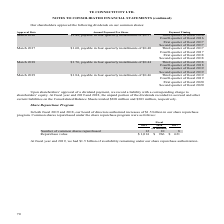According to Te Connectivity's financial document, What was authorized by the board of directors in 2018 and 2019? increases of $1.5 billion in our share repurchase program. The document states: "2019 and 2018, our board of directors authorized increases of $1.5 billion in our share repurchase program. Common shares repurchased under the share ..." Also, What was the availability remaining under the share repurchase authorization in 2019? According to the financial document, $1.5 billion. The relevant text states: "18, our board of directors authorized increases of $1.5 billion in our share repurchase..." Also, Which years was the Repurchase value calculated in? The document contains multiple relevant values: 2019, 2018, 2017. From the document: "2019 2018 2017 2019 2018 2017 2019 2018 2017..." Additionally, Which year was the Number of common shares repurchased the largest? According to the financial document, 2019. The relevant text states: "2019 2018 2017..." Also, can you calculate: What was the change in the Number of common shares repurchased in 2019 from 2018? Based on the calculation: 12-10, the result is 2 (in millions). This is based on the information: "Number of common shares repurchased 12 10 8 Number of common shares repurchased 12 10 8..." The key data points involved are: 10, 12. Also, can you calculate: What was the percentage change in the Number of common shares repurchased in 2019 from 2018? To answer this question, I need to perform calculations using the financial data. The calculation is: (12-10)/10, which equals 20 (percentage). This is based on the information: "Number of common shares repurchased 12 10 8 Number of common shares repurchased 12 10 8..." The key data points involved are: 10, 12. 